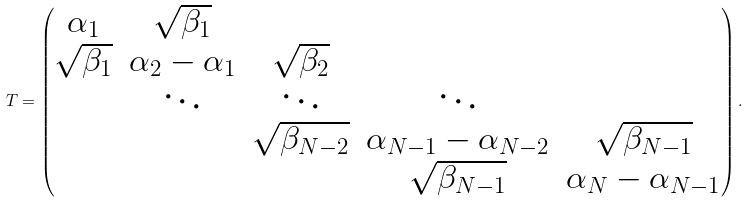Convert formula to latex. <formula><loc_0><loc_0><loc_500><loc_500>T = \begin{pmatrix} \alpha _ { 1 } & \sqrt { \beta _ { 1 } } & & \\ \sqrt { \beta _ { 1 } } & \alpha _ { 2 } - \alpha _ { 1 } & \sqrt { \beta _ { 2 } } & \\ & \ddots & \ddots & \ddots \\ & & \sqrt { \beta _ { N - 2 } } & \alpha _ { N - 1 } - \alpha _ { N - 2 } & \sqrt { \beta _ { N - 1 } } \\ & & & \sqrt { \beta _ { N - 1 } } & \alpha _ { N } - \alpha _ { N - 1 } \end{pmatrix} .</formula> 